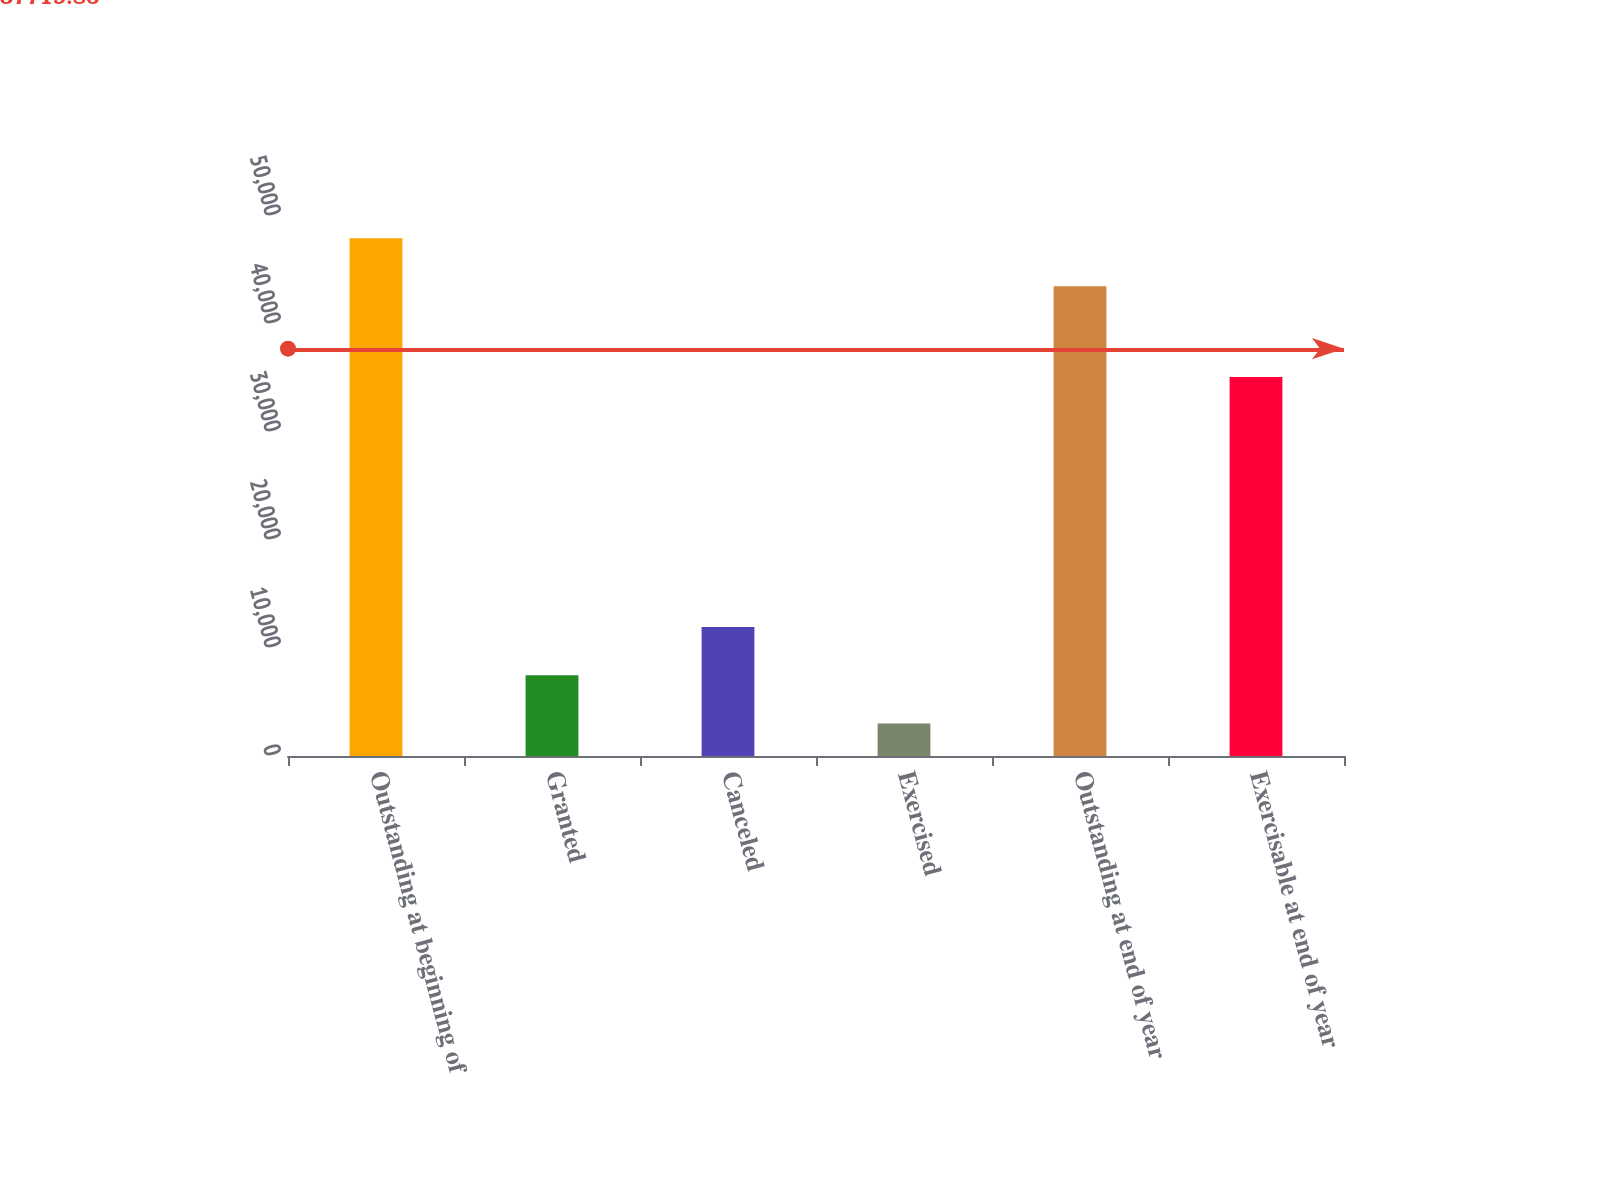<chart> <loc_0><loc_0><loc_500><loc_500><bar_chart><fcel>Outstanding at beginning of<fcel>Granted<fcel>Canceled<fcel>Exercised<fcel>Outstanding at end of year<fcel>Exercisable at end of year<nl><fcel>47950.1<fcel>7477.1<fcel>11942.2<fcel>3012<fcel>43485<fcel>35091<nl></chart> 